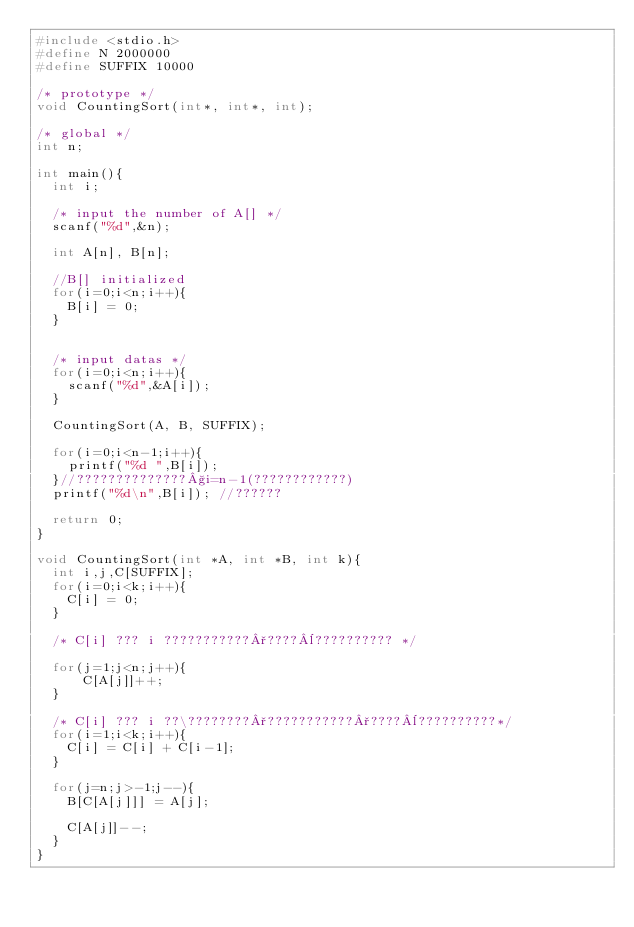<code> <loc_0><loc_0><loc_500><loc_500><_C_>#include <stdio.h>
#define N 2000000
#define SUFFIX 10000

/* prototype */
void CountingSort(int*, int*, int);

/* global */
int n;

int main(){
  int i;
  
  /* input the number of A[] */
  scanf("%d",&n);
  
  int A[n], B[n];

  //B[] initialized
  for(i=0;i<n;i++){
    B[i] = 0;
  }


  /* input datas */
  for(i=0;i<n;i++){
    scanf("%d",&A[i]);
  }
  
  CountingSort(A, B, SUFFIX);
  
  for(i=0;i<n-1;i++){
    printf("%d ",B[i]);
  }//??????????????§i=n-1(????????????)
  printf("%d\n",B[i]); //??????
  
  return 0;
}

void CountingSort(int *A, int *B, int k){
  int i,j,C[SUFFIX];
  for(i=0;i<k;i++){
    C[i] = 0;
  }

  /* C[i] ??? i ???????????°????¨?????????? */

  for(j=1;j<n;j++){
      C[A[j]]++;
  }

  /* C[i] ??? i ??\????????°???????????°????¨??????????*/
  for(i=1;i<k;i++){
    C[i] = C[i] + C[i-1];
  }
  
  for(j=n;j>-1;j--){
    B[C[A[j]]] = A[j];

    C[A[j]]--;
  }
}</code> 